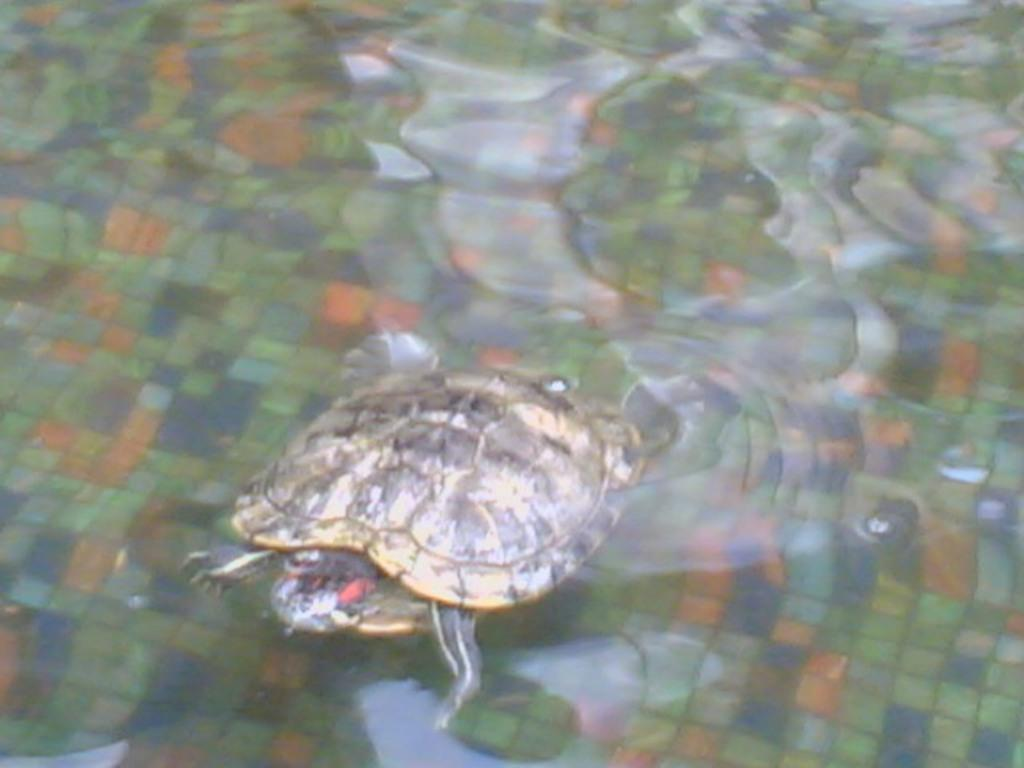What is present in the image? There is water visible in the image, and a tortoise is swimming in the water. Can you describe the tortoise's activity in the image? The tortoise is swimming in the water. What type of rings can be seen on the tortoise's legs in the image? There are no rings visible on the tortoise's legs in the image. How does the tortoise bite the water in the image? The tortoise does not bite the water in the image; it is swimming in the water. 